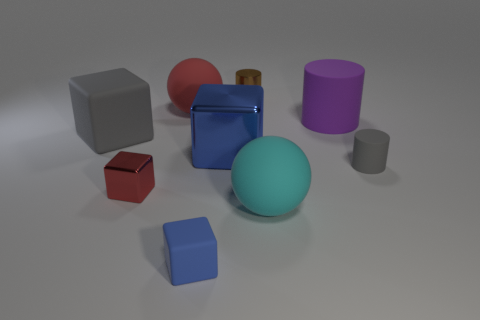Subtract all large rubber blocks. How many blocks are left? 3 Subtract all red blocks. How many blocks are left? 3 Subtract all green spheres. How many blue cubes are left? 2 Add 1 small cylinders. How many objects exist? 10 Subtract all balls. How many objects are left? 7 Subtract all brown blocks. Subtract all red cylinders. How many blocks are left? 4 Subtract all small blue blocks. Subtract all blue matte blocks. How many objects are left? 7 Add 1 small brown cylinders. How many small brown cylinders are left? 2 Add 5 cyan rubber spheres. How many cyan rubber spheres exist? 6 Subtract 0 green balls. How many objects are left? 9 